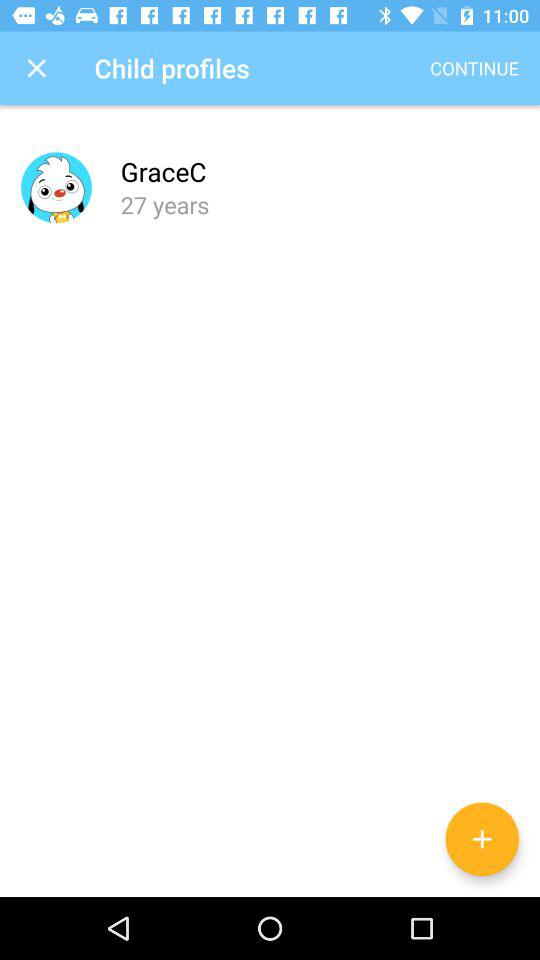How old is the profile with a penguin holding a yellow badge?
Answer the question using a single word or phrase. 27 years 